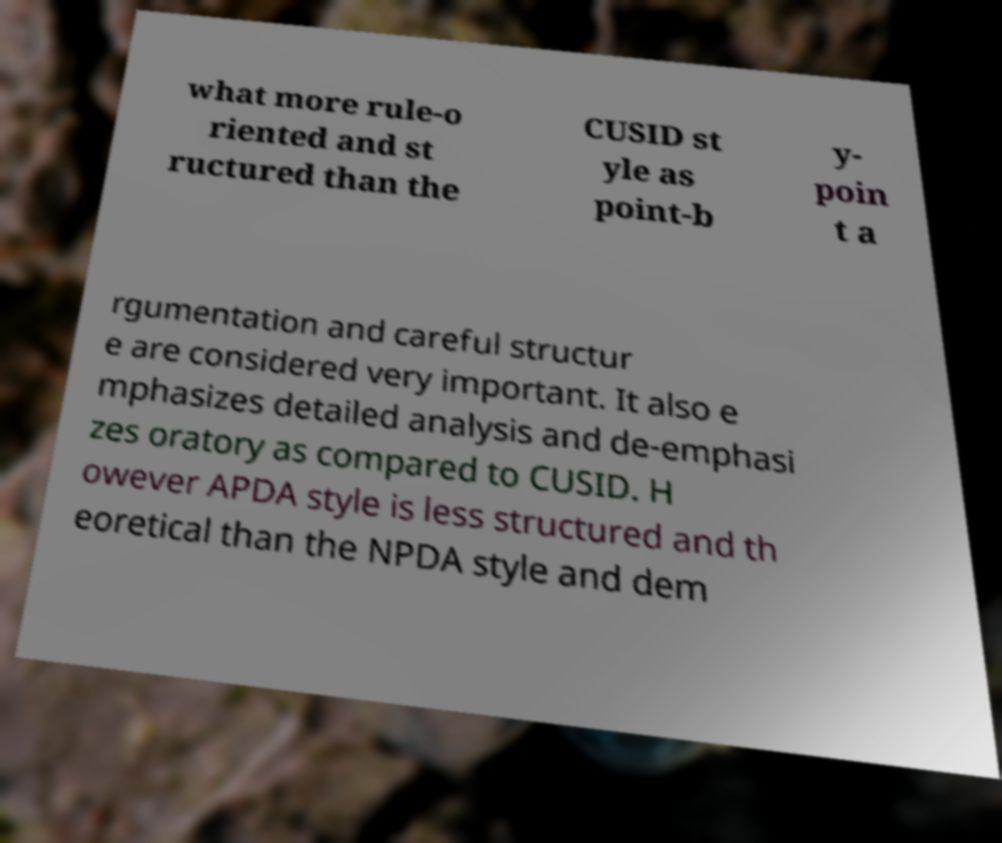For documentation purposes, I need the text within this image transcribed. Could you provide that? what more rule-o riented and st ructured than the CUSID st yle as point-b y- poin t a rgumentation and careful structur e are considered very important. It also e mphasizes detailed analysis and de-emphasi zes oratory as compared to CUSID. H owever APDA style is less structured and th eoretical than the NPDA style and dem 